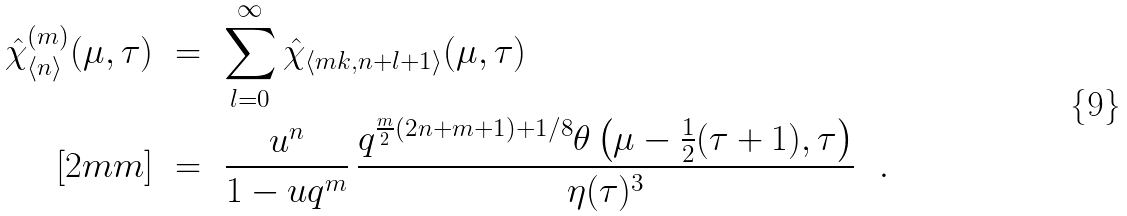<formula> <loc_0><loc_0><loc_500><loc_500>\hat { \chi } _ { \langle n \rangle } ^ { ( m ) } ( \mu , \tau ) & \ = \ \sum _ { l = 0 } ^ { \infty } \hat { \chi } _ { \langle m k , n + l + 1 \rangle } ( \mu , \tau ) \\ [ 2 m m ] & \ = \ \frac { u ^ { n } } { 1 - u q ^ { m } } \, \frac { q ^ { \frac { m } { 2 } ( 2 n + m + 1 ) + 1 / 8 } \theta \left ( \mu - \frac { 1 } { 2 } ( \tau + 1 ) , \tau \right ) } { \eta ( \tau ) ^ { 3 } } \ \ .</formula> 